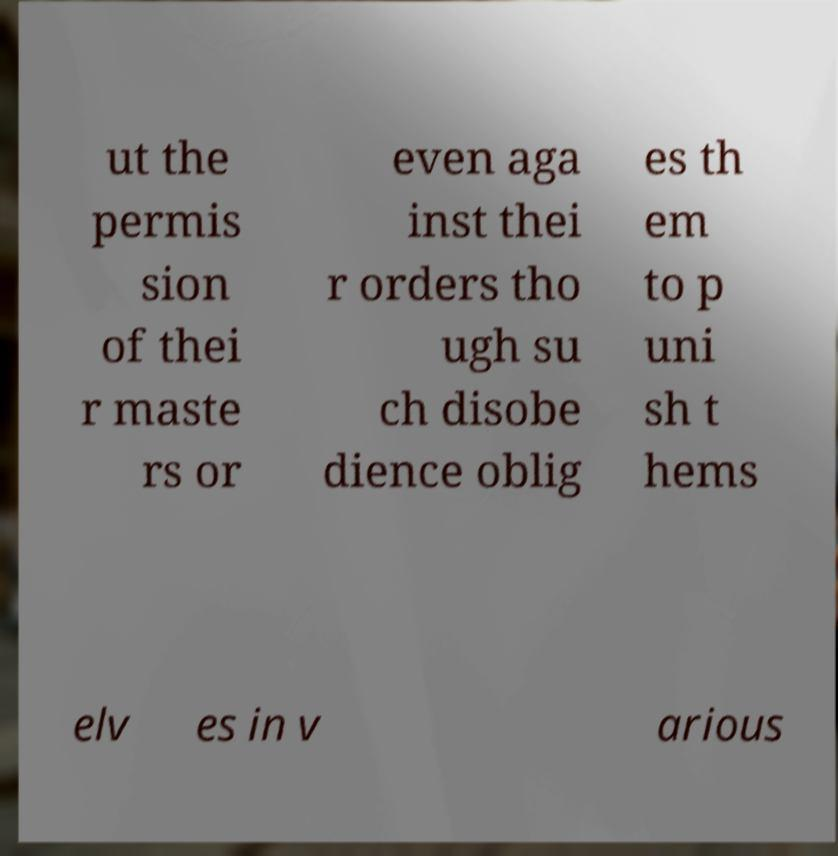Could you assist in decoding the text presented in this image and type it out clearly? ut the permis sion of thei r maste rs or even aga inst thei r orders tho ugh su ch disobe dience oblig es th em to p uni sh t hems elv es in v arious 